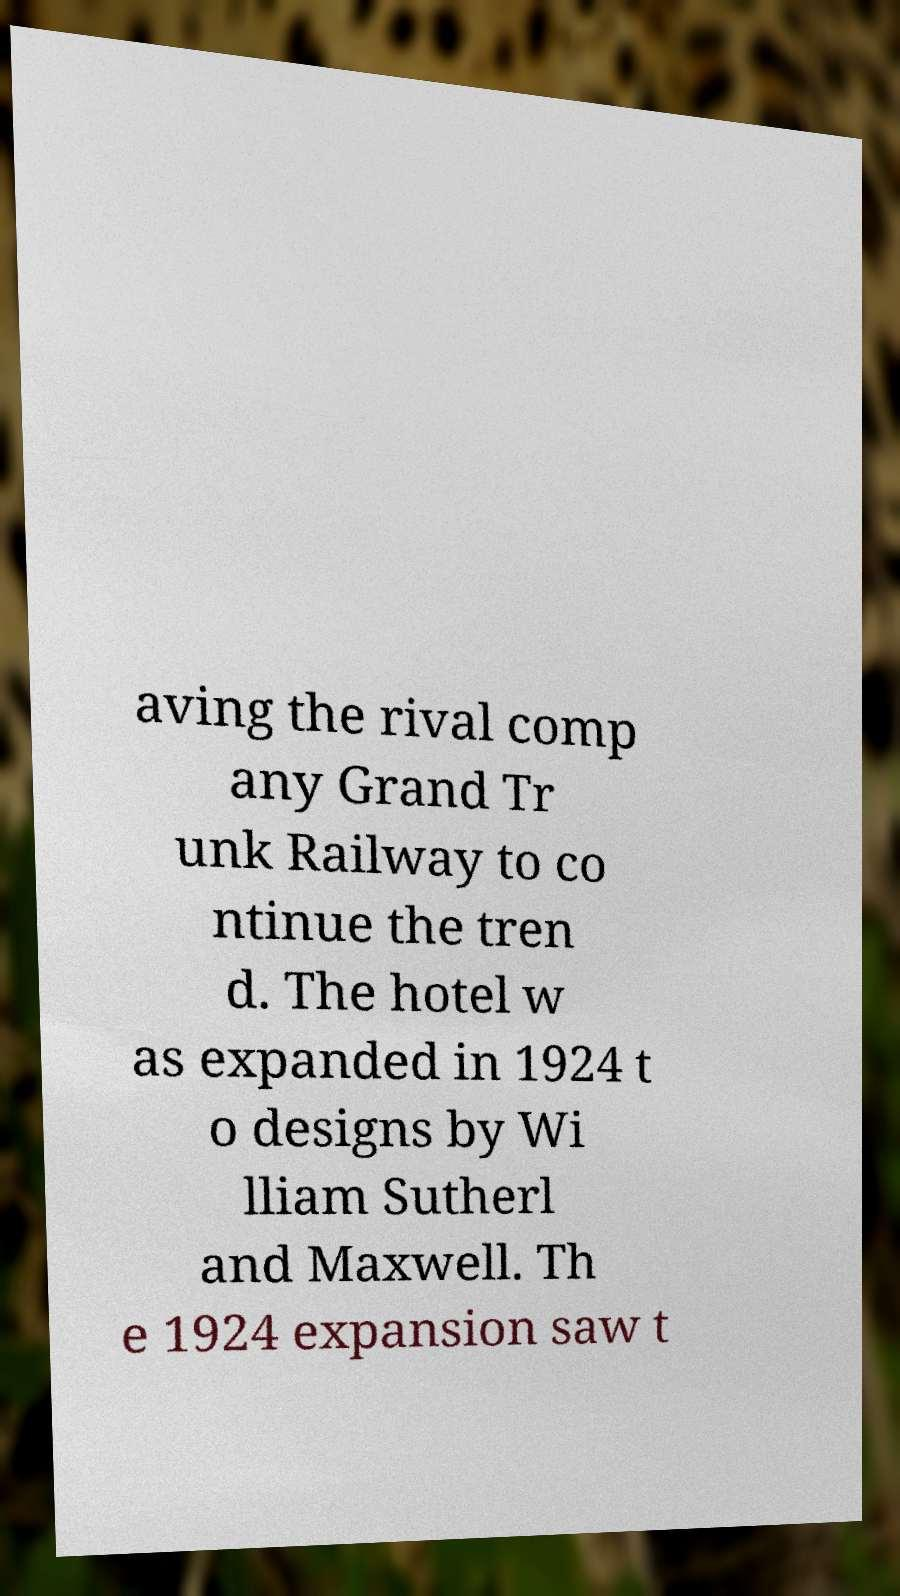For documentation purposes, I need the text within this image transcribed. Could you provide that? aving the rival comp any Grand Tr unk Railway to co ntinue the tren d. The hotel w as expanded in 1924 t o designs by Wi lliam Sutherl and Maxwell. Th e 1924 expansion saw t 